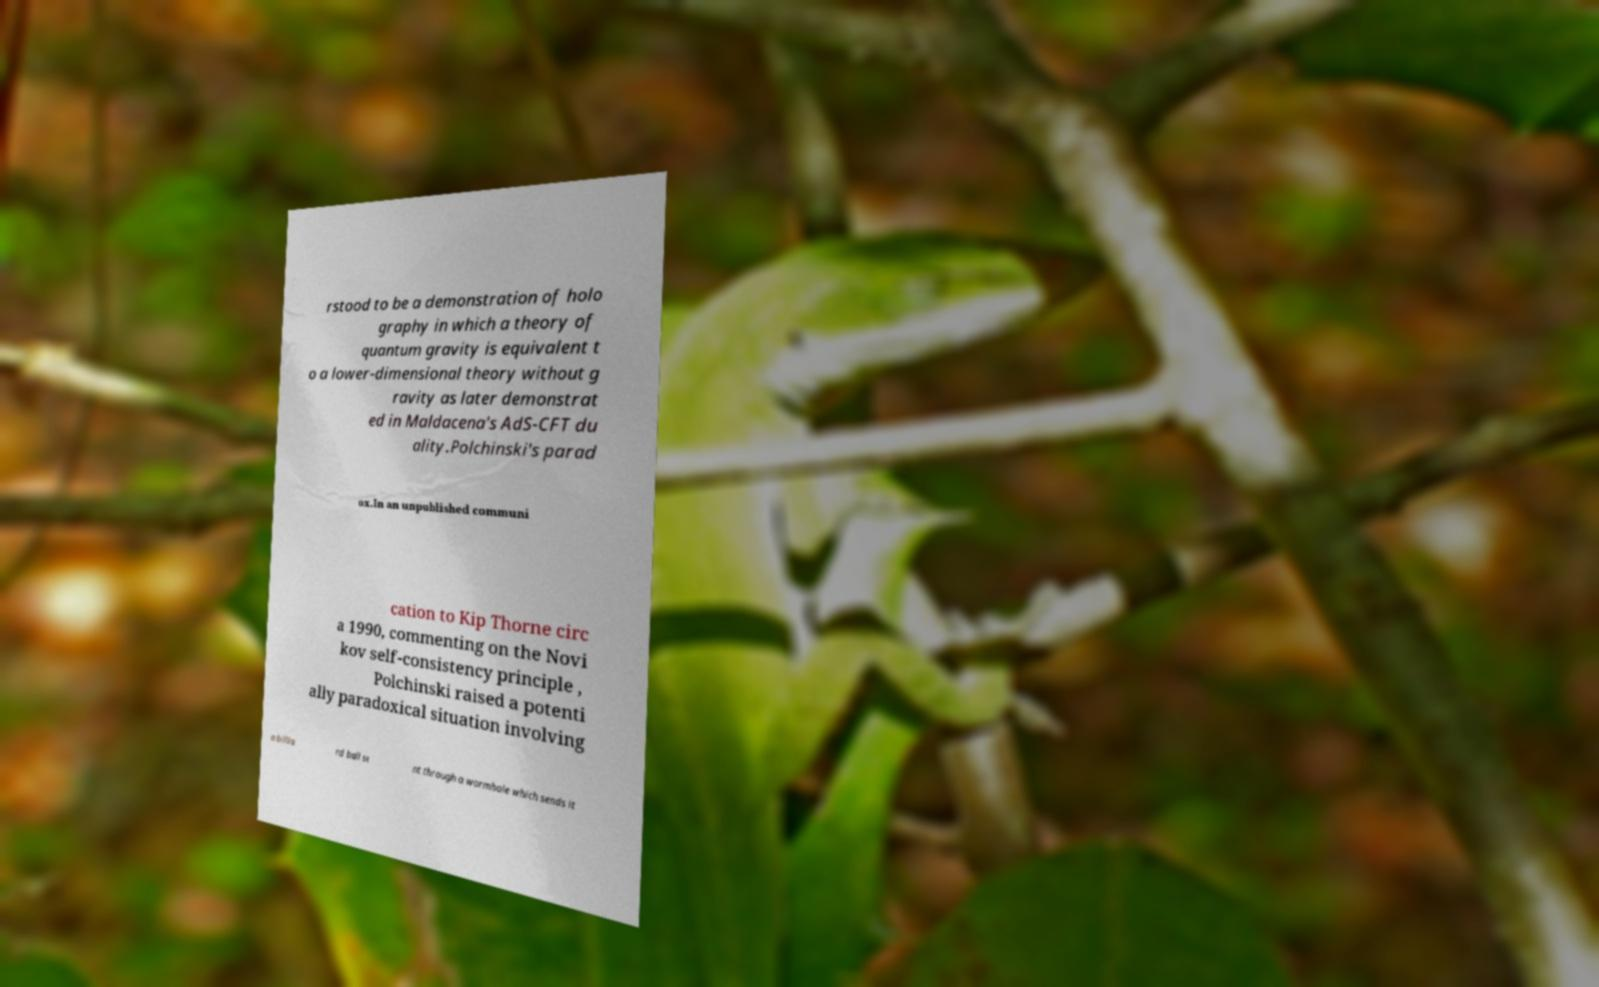There's text embedded in this image that I need extracted. Can you transcribe it verbatim? rstood to be a demonstration of holo graphy in which a theory of quantum gravity is equivalent t o a lower-dimensional theory without g ravity as later demonstrat ed in Maldacena's AdS-CFT du ality.Polchinski's parad ox.In an unpublished communi cation to Kip Thorne circ a 1990, commenting on the Novi kov self-consistency principle , Polchinski raised a potenti ally paradoxical situation involving a billia rd ball se nt through a wormhole which sends it 